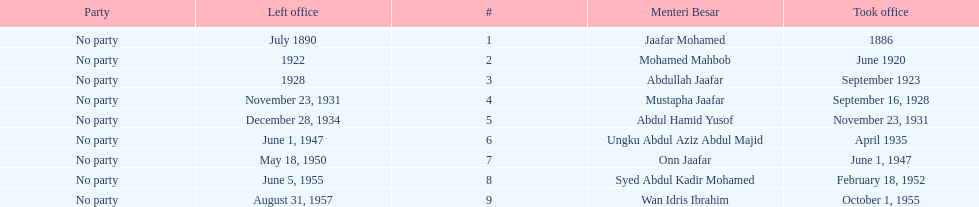Who took office after onn jaafar? Syed Abdul Kadir Mohamed. 